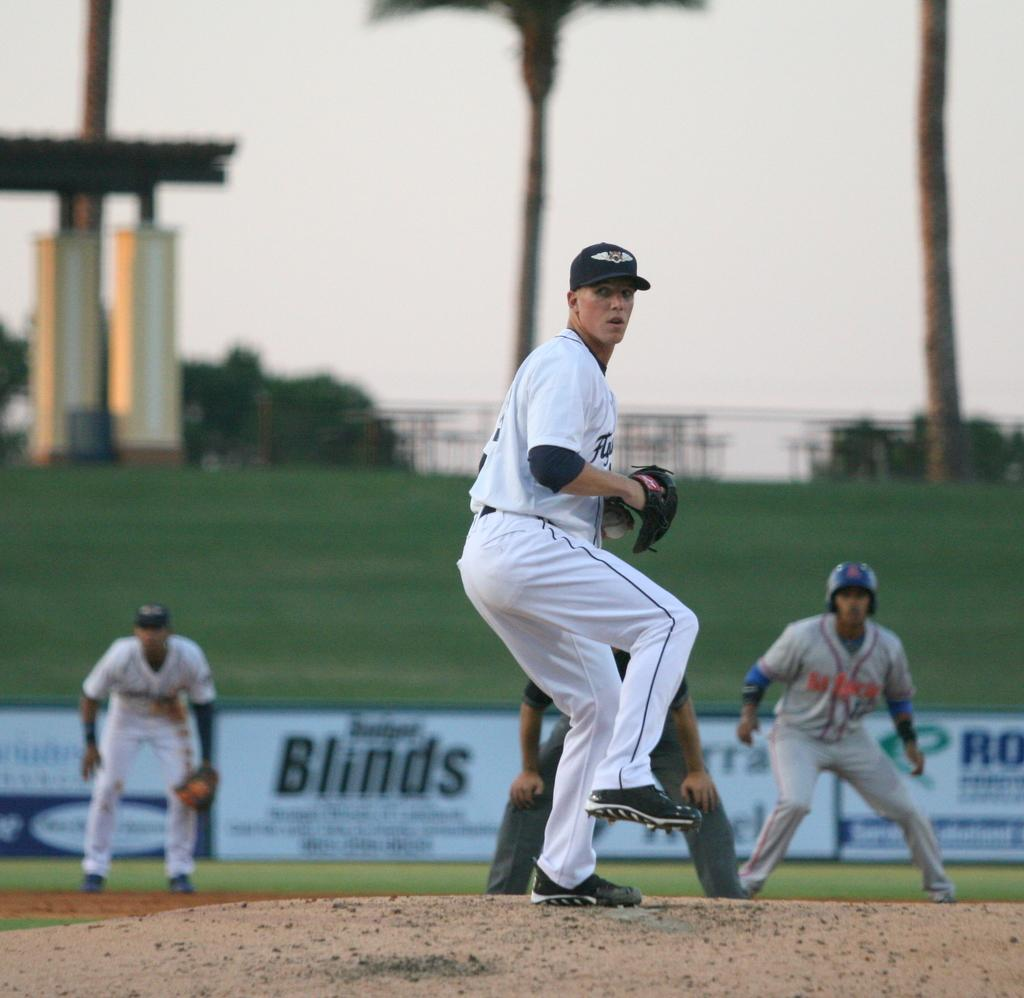<image>
Present a compact description of the photo's key features. A baseball player infront of a banner that says "Blinds" 